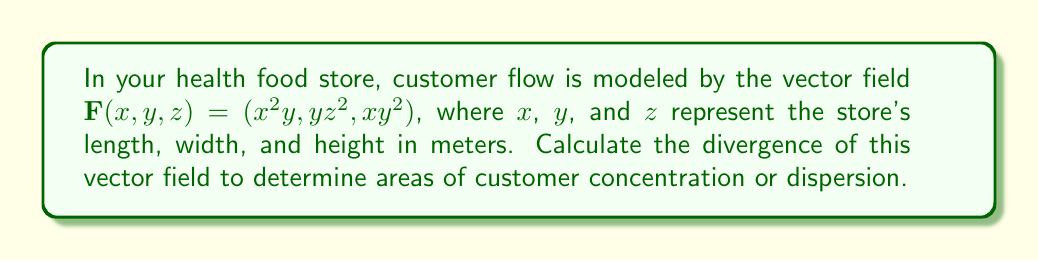Give your solution to this math problem. To solve this problem, we need to calculate the divergence of the given vector field. The divergence of a vector field $\mathbf{F}(x,y,z) = (F_1, F_2, F_3)$ is defined as:

$$\nabla \cdot \mathbf{F} = \frac{\partial F_1}{\partial x} + \frac{\partial F_2}{\partial y} + \frac{\partial F_3}{\partial z}$$

For our vector field $\mathbf{F}(x,y,z) = (x^2y, yz^2, xy^2)$:

1. Calculate $\frac{\partial F_1}{\partial x}$:
   $F_1 = x^2y$, so $\frac{\partial F_1}{\partial x} = 2xy$

2. Calculate $\frac{\partial F_2}{\partial y}$:
   $F_2 = yz^2$, so $\frac{\partial F_2}{\partial y} = z^2$

3. Calculate $\frac{\partial F_3}{\partial z}$:
   $F_3 = xy^2$, so $\frac{\partial F_3}{\partial z} = 0$

Now, we sum these partial derivatives:

$$\nabla \cdot \mathbf{F} = \frac{\partial F_1}{\partial x} + \frac{\partial F_2}{\partial y} + \frac{\partial F_3}{\partial z}$$
$$\nabla \cdot \mathbf{F} = 2xy + z^2 + 0$$
$$\nabla \cdot \mathbf{F} = 2xy + z^2$$

This result represents the divergence of the customer flow vector field in your health food store.
Answer: $2xy + z^2$ 